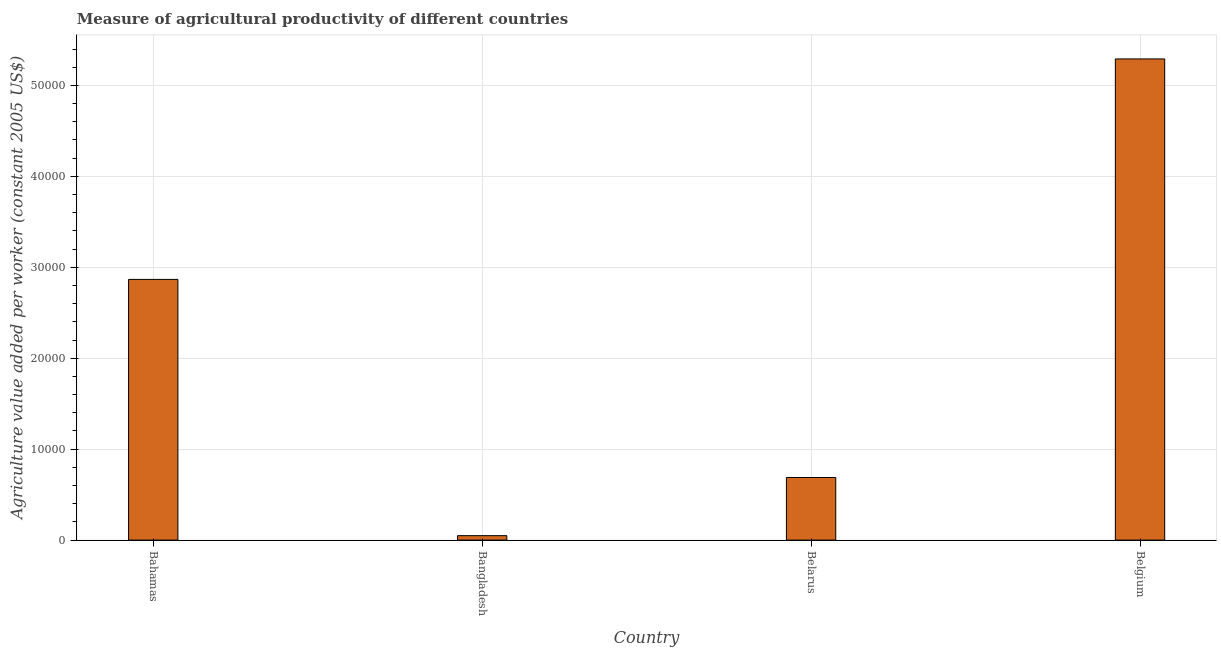Does the graph contain any zero values?
Make the answer very short. No. Does the graph contain grids?
Offer a very short reply. Yes. What is the title of the graph?
Provide a short and direct response. Measure of agricultural productivity of different countries. What is the label or title of the Y-axis?
Provide a succinct answer. Agriculture value added per worker (constant 2005 US$). What is the agriculture value added per worker in Bahamas?
Offer a terse response. 2.87e+04. Across all countries, what is the maximum agriculture value added per worker?
Offer a very short reply. 5.29e+04. Across all countries, what is the minimum agriculture value added per worker?
Your response must be concise. 487.34. In which country was the agriculture value added per worker minimum?
Ensure brevity in your answer.  Bangladesh. What is the sum of the agriculture value added per worker?
Your answer should be compact. 8.90e+04. What is the difference between the agriculture value added per worker in Bahamas and Belarus?
Offer a very short reply. 2.18e+04. What is the average agriculture value added per worker per country?
Make the answer very short. 2.22e+04. What is the median agriculture value added per worker?
Your answer should be very brief. 1.78e+04. In how many countries, is the agriculture value added per worker greater than 36000 US$?
Offer a terse response. 1. What is the ratio of the agriculture value added per worker in Bangladesh to that in Belgium?
Give a very brief answer. 0.01. What is the difference between the highest and the second highest agriculture value added per worker?
Keep it short and to the point. 2.42e+04. What is the difference between the highest and the lowest agriculture value added per worker?
Your answer should be compact. 5.24e+04. How many bars are there?
Ensure brevity in your answer.  4. Are all the bars in the graph horizontal?
Give a very brief answer. No. How many countries are there in the graph?
Offer a terse response. 4. Are the values on the major ticks of Y-axis written in scientific E-notation?
Provide a succinct answer. No. What is the Agriculture value added per worker (constant 2005 US$) of Bahamas?
Offer a terse response. 2.87e+04. What is the Agriculture value added per worker (constant 2005 US$) of Bangladesh?
Offer a terse response. 487.34. What is the Agriculture value added per worker (constant 2005 US$) in Belarus?
Keep it short and to the point. 6885.24. What is the Agriculture value added per worker (constant 2005 US$) of Belgium?
Provide a succinct answer. 5.29e+04. What is the difference between the Agriculture value added per worker (constant 2005 US$) in Bahamas and Bangladesh?
Ensure brevity in your answer.  2.82e+04. What is the difference between the Agriculture value added per worker (constant 2005 US$) in Bahamas and Belarus?
Offer a terse response. 2.18e+04. What is the difference between the Agriculture value added per worker (constant 2005 US$) in Bahamas and Belgium?
Your answer should be very brief. -2.42e+04. What is the difference between the Agriculture value added per worker (constant 2005 US$) in Bangladesh and Belarus?
Your answer should be very brief. -6397.9. What is the difference between the Agriculture value added per worker (constant 2005 US$) in Bangladesh and Belgium?
Your answer should be compact. -5.24e+04. What is the difference between the Agriculture value added per worker (constant 2005 US$) in Belarus and Belgium?
Offer a very short reply. -4.60e+04. What is the ratio of the Agriculture value added per worker (constant 2005 US$) in Bahamas to that in Bangladesh?
Keep it short and to the point. 58.83. What is the ratio of the Agriculture value added per worker (constant 2005 US$) in Bahamas to that in Belarus?
Your response must be concise. 4.16. What is the ratio of the Agriculture value added per worker (constant 2005 US$) in Bahamas to that in Belgium?
Provide a short and direct response. 0.54. What is the ratio of the Agriculture value added per worker (constant 2005 US$) in Bangladesh to that in Belarus?
Make the answer very short. 0.07. What is the ratio of the Agriculture value added per worker (constant 2005 US$) in Bangladesh to that in Belgium?
Give a very brief answer. 0.01. What is the ratio of the Agriculture value added per worker (constant 2005 US$) in Belarus to that in Belgium?
Your answer should be very brief. 0.13. 